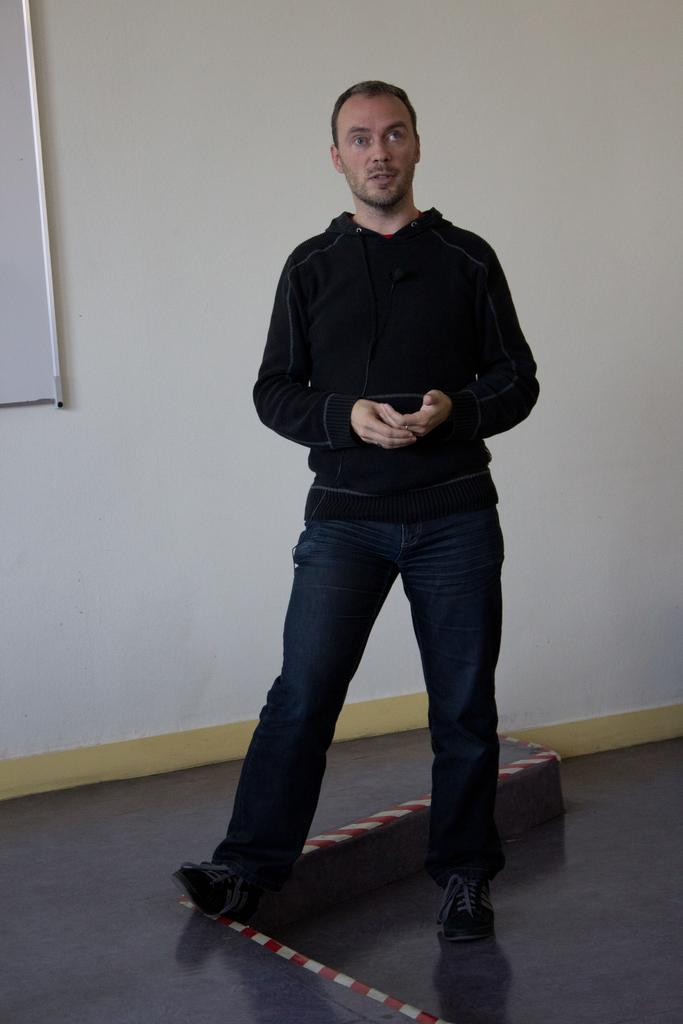What is the primary subject in the image? There is a person standing on the ground in the image. Can you describe any objects or features in the background? There is a board on the wall on the left side of the image. What type of quilt is being used in the competition in the image? There is no quilt or competition present in the image; it only features a person standing on the ground and a board on the wall. 